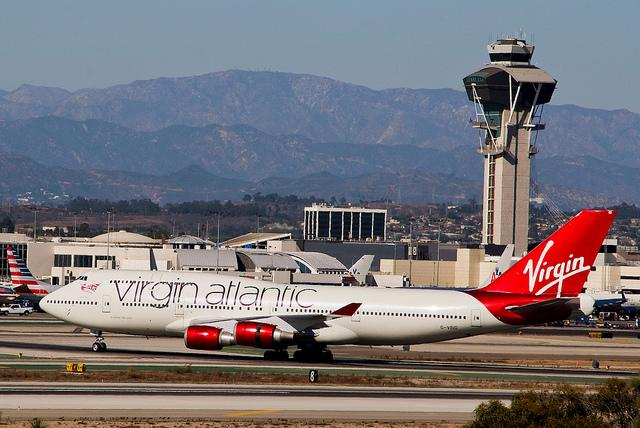Who owns the company whose name appears here? Please explain your reasoning. richard branson. The airline company's name is written on the side. the man who owns the airline is internet searchable. 